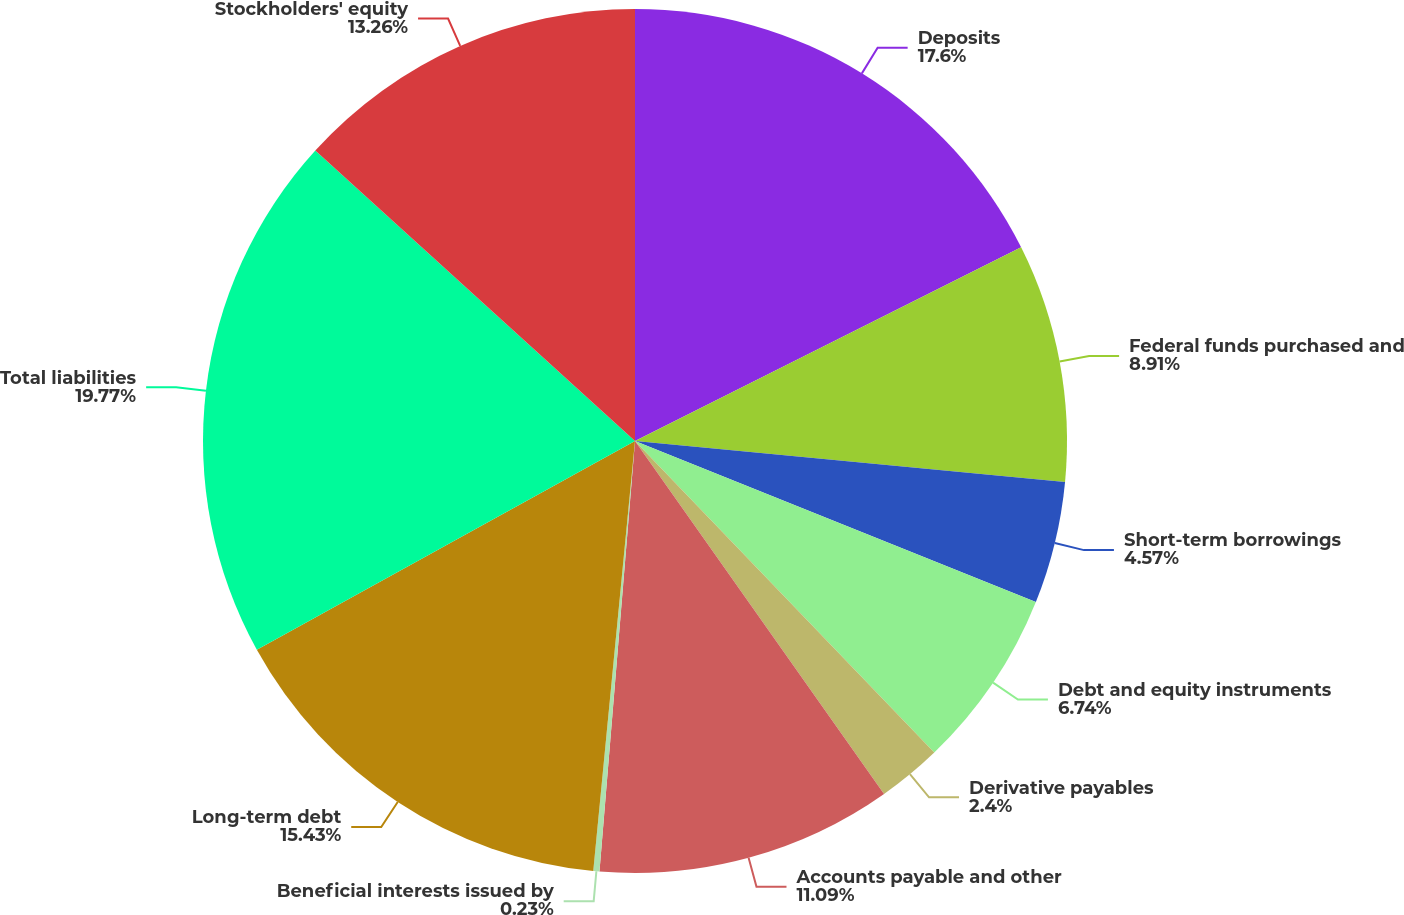Convert chart. <chart><loc_0><loc_0><loc_500><loc_500><pie_chart><fcel>Deposits<fcel>Federal funds purchased and<fcel>Short-term borrowings<fcel>Debt and equity instruments<fcel>Derivative payables<fcel>Accounts payable and other<fcel>Beneficial interests issued by<fcel>Long-term debt<fcel>Total liabilities<fcel>Stockholders' equity<nl><fcel>17.6%<fcel>8.91%<fcel>4.57%<fcel>6.74%<fcel>2.4%<fcel>11.09%<fcel>0.23%<fcel>15.43%<fcel>19.77%<fcel>13.26%<nl></chart> 